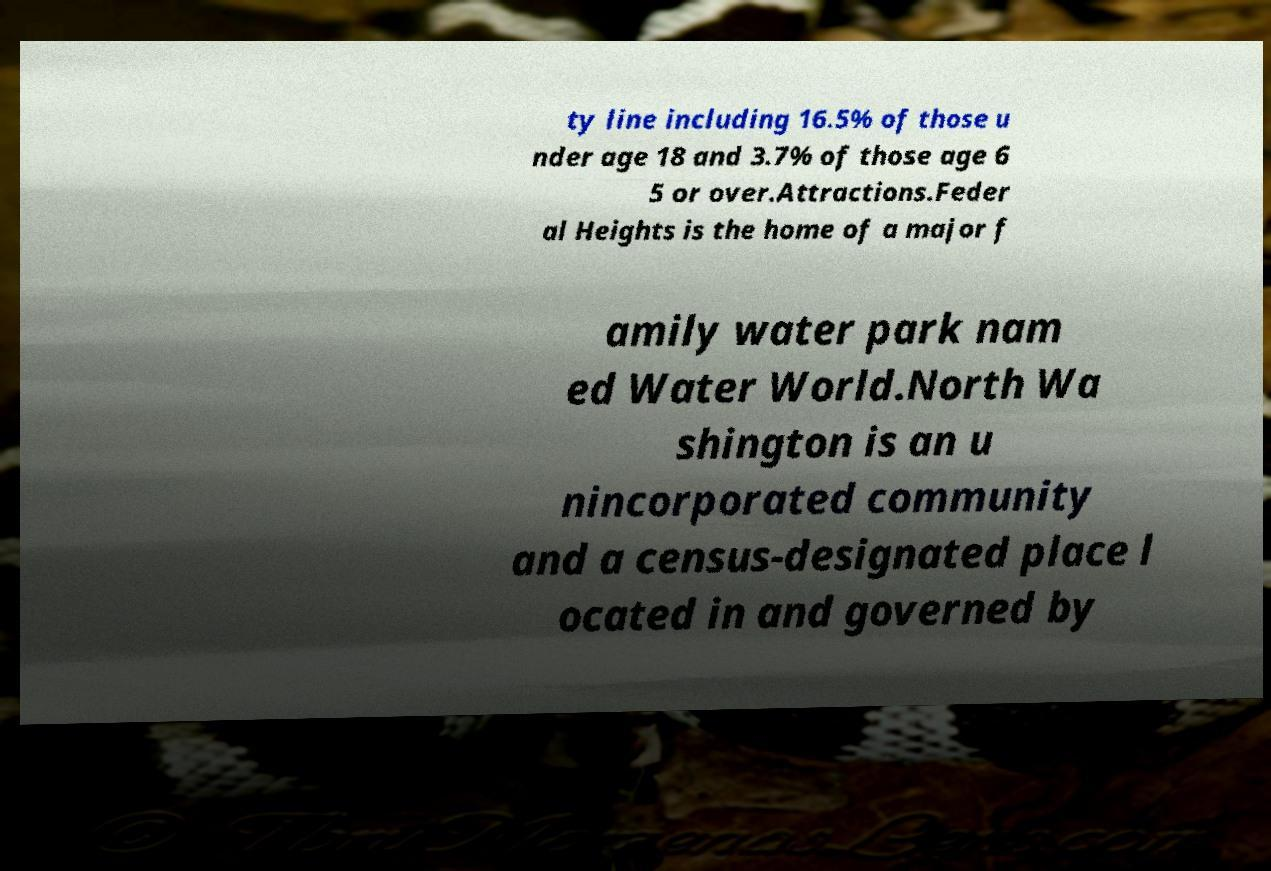There's text embedded in this image that I need extracted. Can you transcribe it verbatim? ty line including 16.5% of those u nder age 18 and 3.7% of those age 6 5 or over.Attractions.Feder al Heights is the home of a major f amily water park nam ed Water World.North Wa shington is an u nincorporated community and a census-designated place l ocated in and governed by 